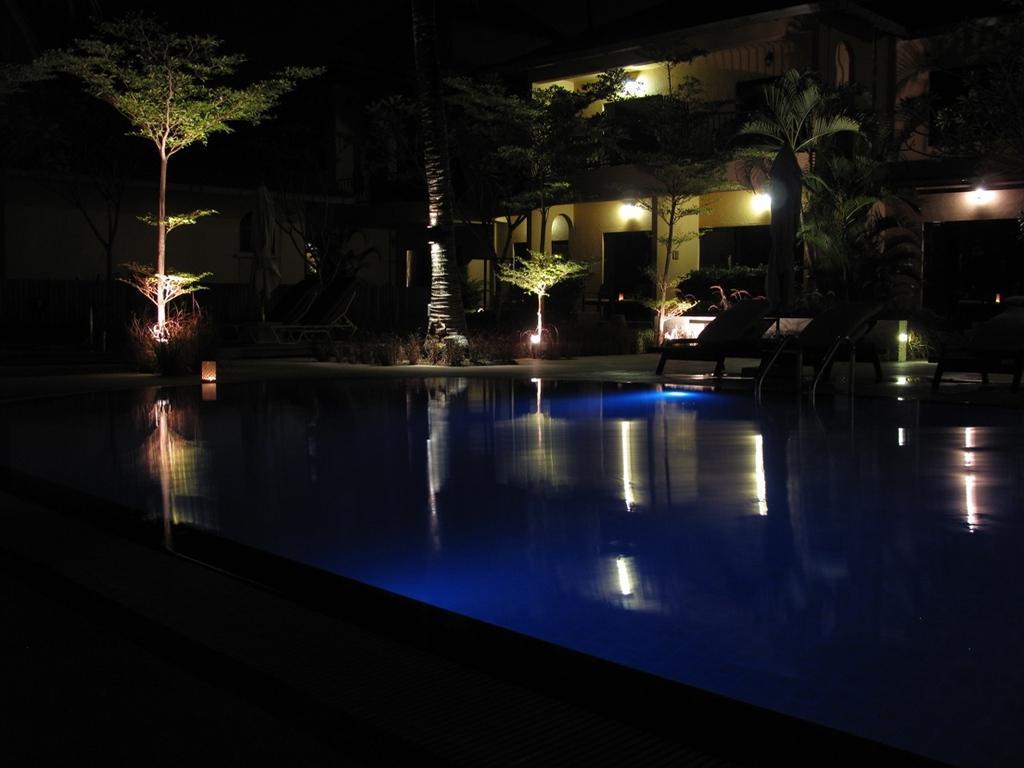In one or two sentences, can you explain what this image depicts? In the image there is pool in the front and a building behind it with trees in front of it and there are lights inside the building. 